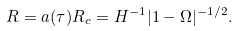<formula> <loc_0><loc_0><loc_500><loc_500>R = a ( \tau ) R _ { c } = H ^ { - 1 } | 1 - \Omega | ^ { - 1 / 2 } .</formula> 